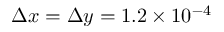Convert formula to latex. <formula><loc_0><loc_0><loc_500><loc_500>\Delta x = \Delta y = 1 . 2 \times 1 0 ^ { - 4 }</formula> 